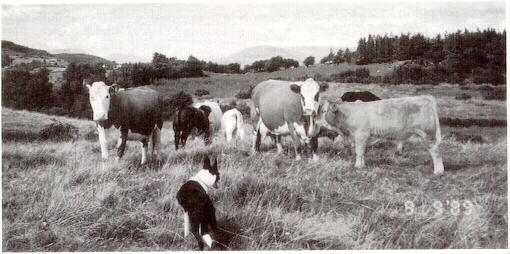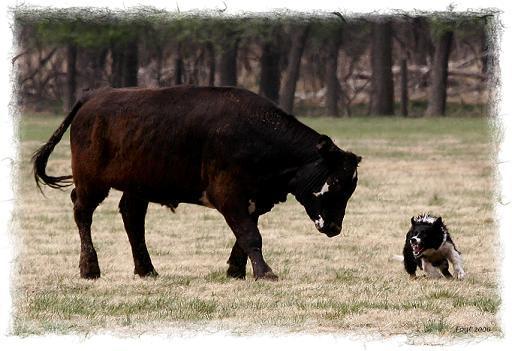The first image is the image on the left, the second image is the image on the right. For the images shown, is this caption "The dog in the left image is facing towards the left." true? Answer yes or no. No. The first image is the image on the left, the second image is the image on the right. Assess this claim about the two images: "Dogs herd livestock within a fence line.". Correct or not? Answer yes or no. No. 